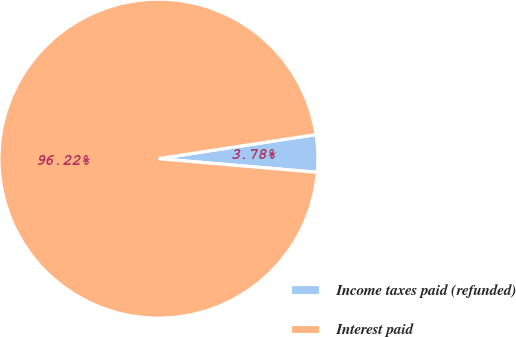Convert chart to OTSL. <chart><loc_0><loc_0><loc_500><loc_500><pie_chart><fcel>Income taxes paid (refunded)<fcel>Interest paid<nl><fcel>3.78%<fcel>96.22%<nl></chart> 